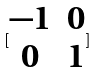Convert formula to latex. <formula><loc_0><loc_0><loc_500><loc_500>[ \begin{matrix} - 1 & 0 \\ 0 & 1 \end{matrix} ]</formula> 